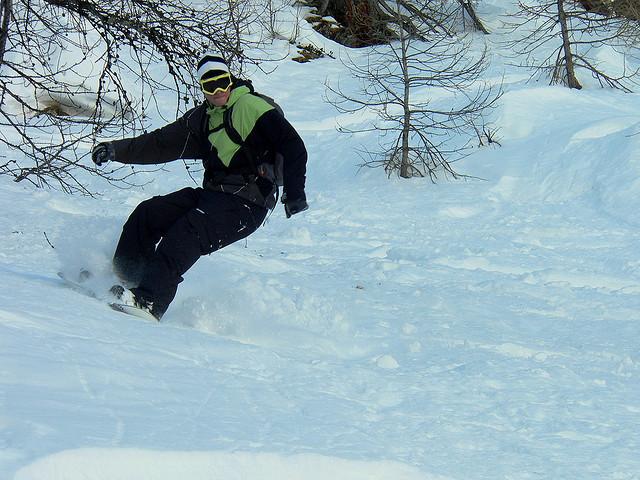Is the snowboarder participating in a professional competition or in a leisure sport?
Give a very brief answer. Leisure. Is the snowboarder wearing red gloves?
Short answer required. No. What angle do you think the snowboarder is at?
Be succinct. 45. 